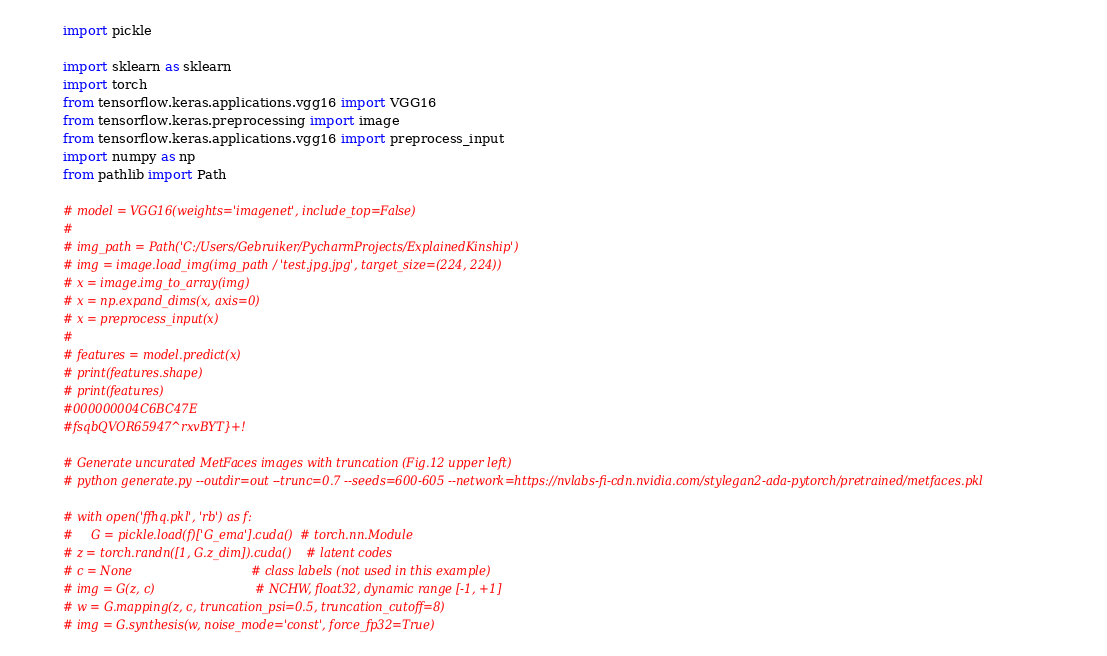Convert code to text. <code><loc_0><loc_0><loc_500><loc_500><_Python_>import pickle

import sklearn as sklearn
import torch
from tensorflow.keras.applications.vgg16 import VGG16
from tensorflow.keras.preprocessing import image
from tensorflow.keras.applications.vgg16 import preprocess_input
import numpy as np
from pathlib import Path

# model = VGG16(weights='imagenet', include_top=False)
#
# img_path = Path('C:/Users/Gebruiker/PycharmProjects/ExplainedKinship')
# img = image.load_img(img_path / 'test.jpg.jpg', target_size=(224, 224))
# x = image.img_to_array(img)
# x = np.expand_dims(x, axis=0)
# x = preprocess_input(x)
#
# features = model.predict(x)
# print(features.shape)
# print(features)
#000000004C6BC47E
#fsqbQVOR65947^rxvBYT}+!

# Generate uncurated MetFaces images with truncation (Fig.12 upper left)
# python generate.py --outdir=out --trunc=0.7 --seeds=600-605 --network=https://nvlabs-fi-cdn.nvidia.com/stylegan2-ada-pytorch/pretrained/metfaces.pkl

# with open('ffhq.pkl', 'rb') as f:
#     G = pickle.load(f)['G_ema'].cuda()  # torch.nn.Module
# z = torch.randn([1, G.z_dim]).cuda()    # latent codes
# c = None                                # class labels (not used in this example)
# img = G(z, c)                           # NCHW, float32, dynamic range [-1, +1]
# w = G.mapping(z, c, truncation_psi=0.5, truncation_cutoff=8)
# img = G.synthesis(w, noise_mode='const', force_fp32=True)

</code> 